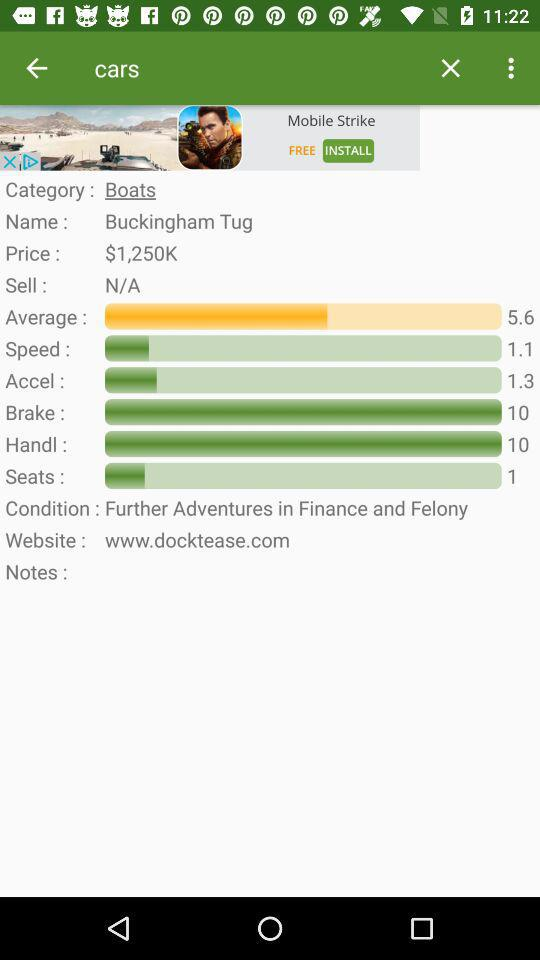What is the price of the boat?
Answer the question using a single word or phrase. $1,250K 